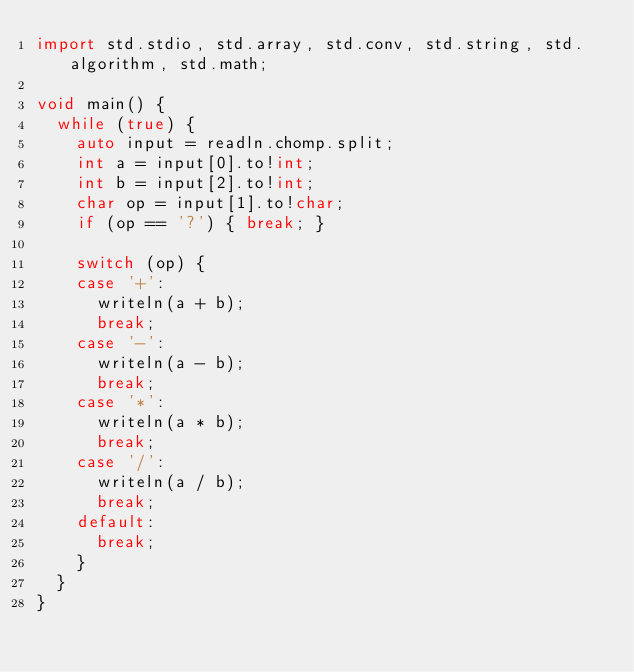Convert code to text. <code><loc_0><loc_0><loc_500><loc_500><_D_>import std.stdio, std.array, std.conv, std.string, std.algorithm, std.math;

void main() {
  while (true) {
    auto input = readln.chomp.split;
    int a = input[0].to!int;
    int b = input[2].to!int;
    char op = input[1].to!char;
    if (op == '?') { break; }

    switch (op) {
    case '+':
      writeln(a + b);
      break;
    case '-':
      writeln(a - b);
      break;
    case '*':
      writeln(a * b);
      break;
    case '/':
      writeln(a / b);
      break;
    default:
      break;
    }
  }
}</code> 